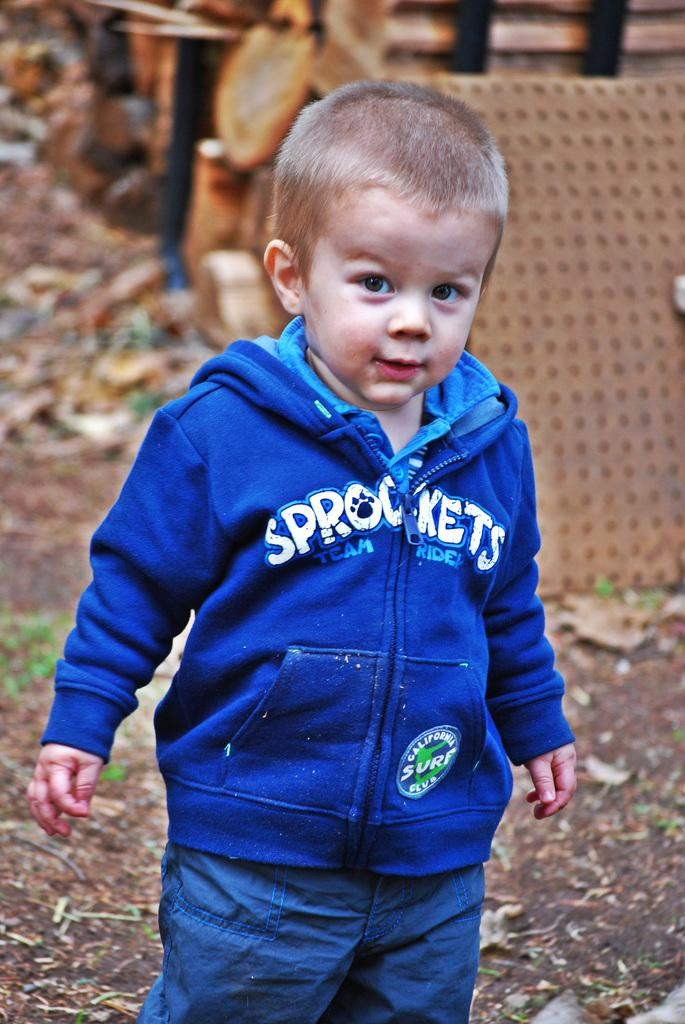<image>
Summarize the visual content of the image. A young toddler in a blue and white Sprockets hoodie is standing in the yard. 